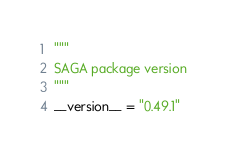Convert code to text. <code><loc_0><loc_0><loc_500><loc_500><_Python_>"""
SAGA package version
"""
__version__ = "0.49.1"
</code> 